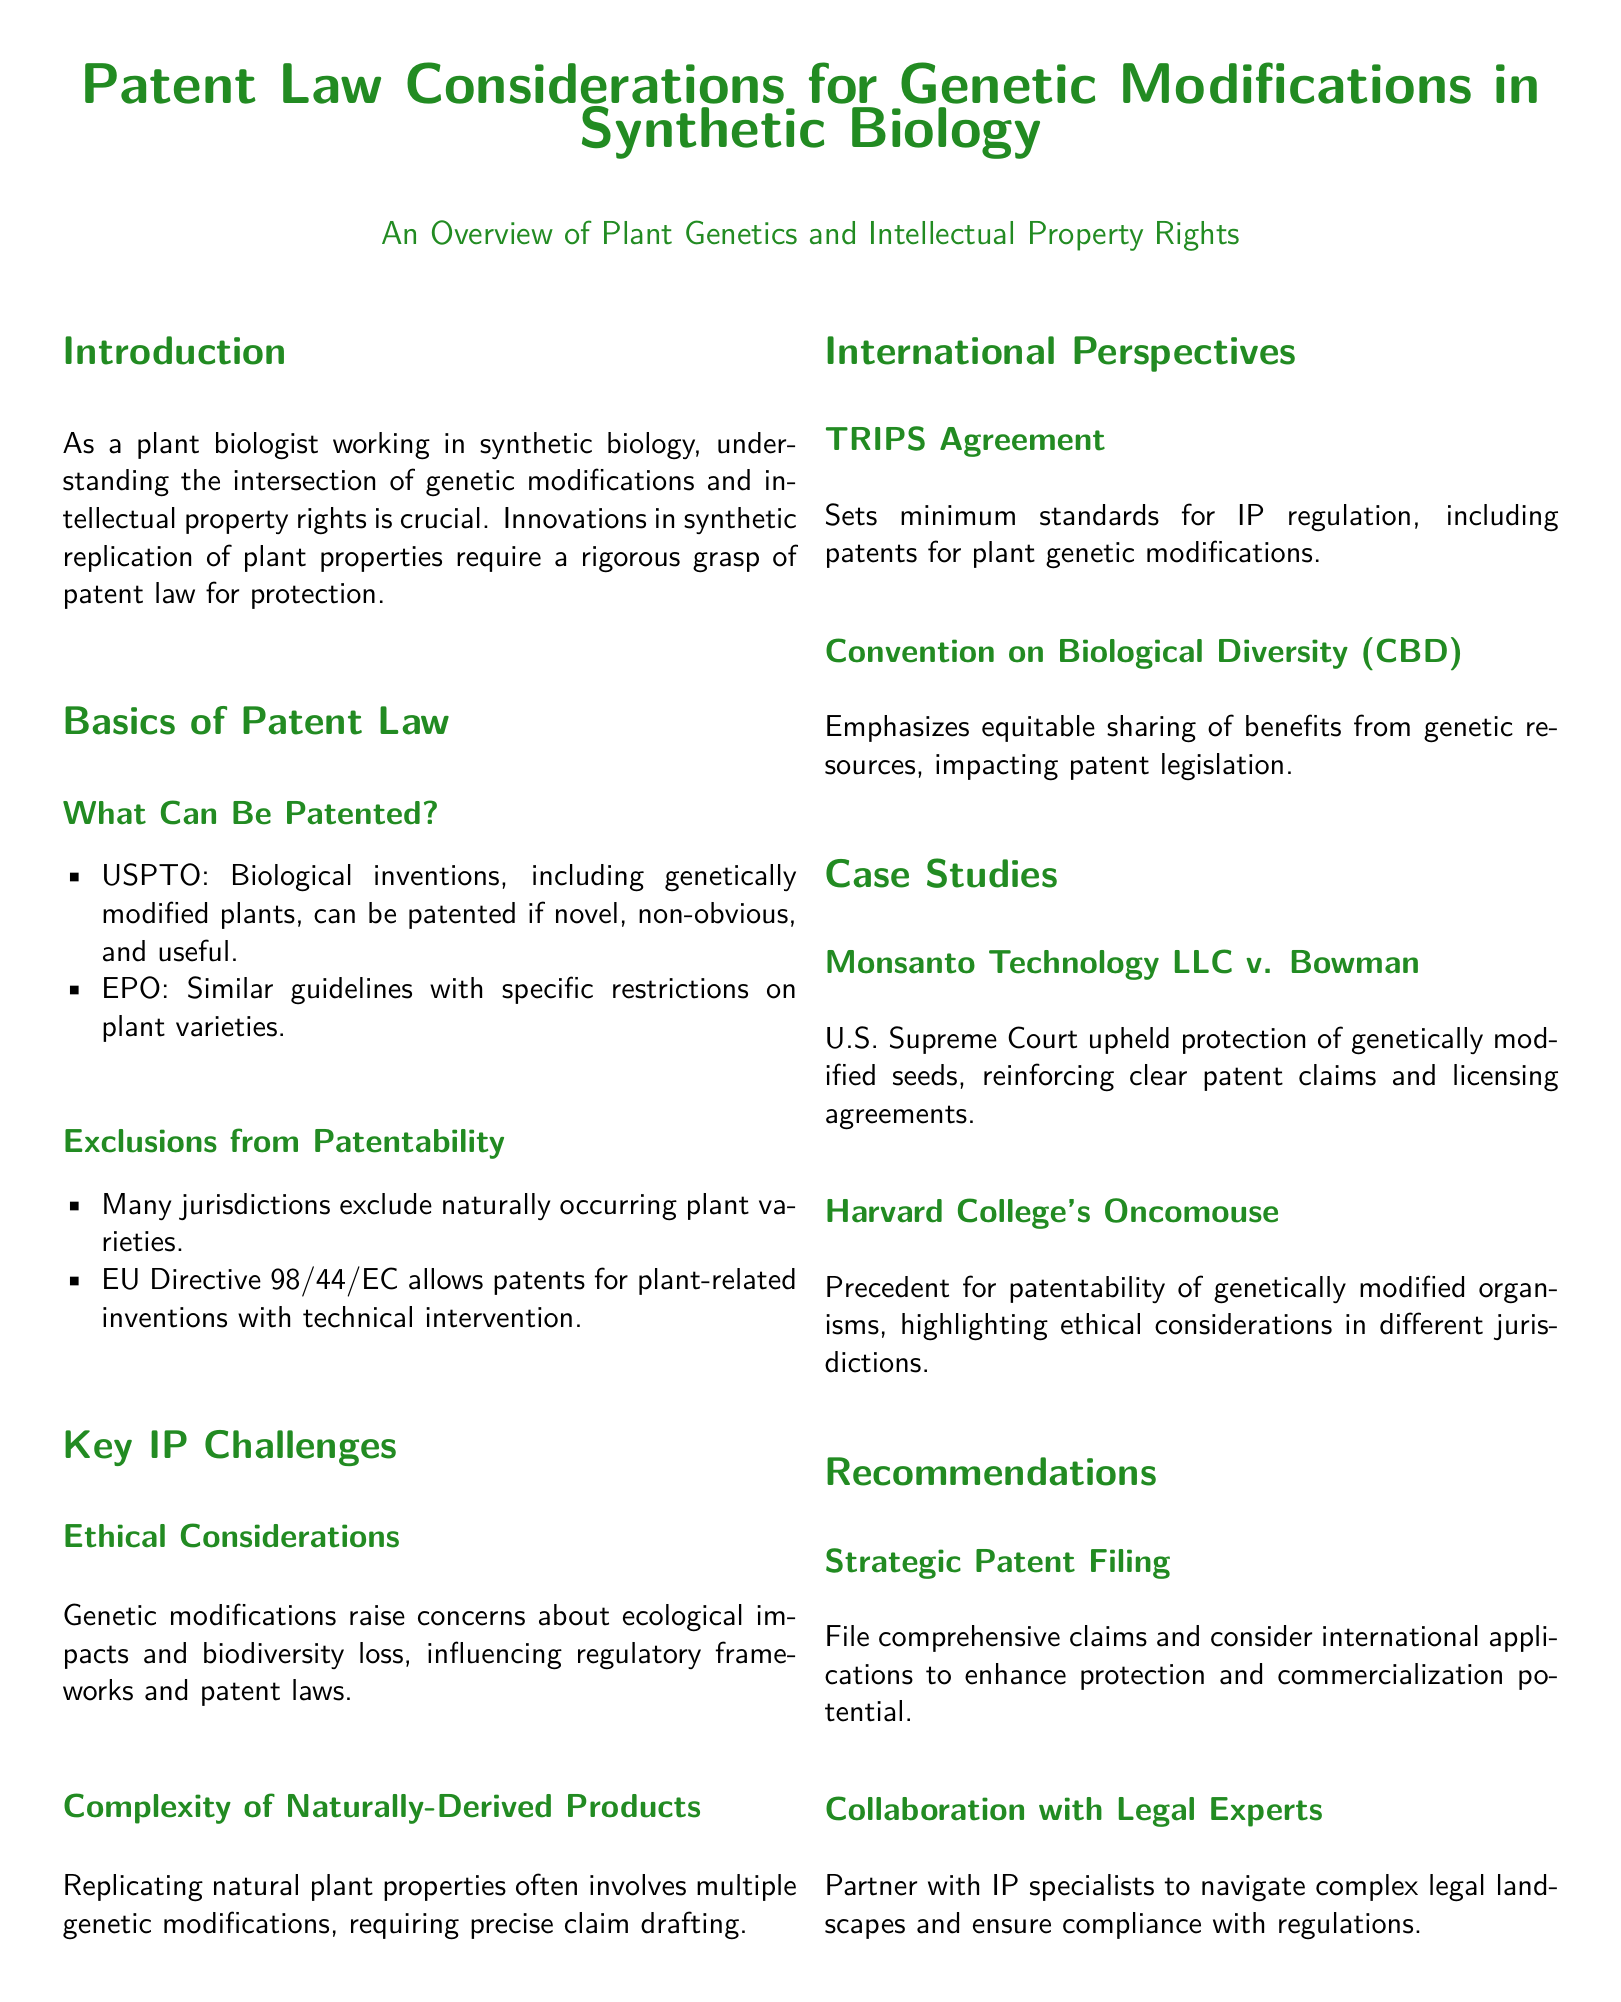What is the title of the document? The title is presented prominently at the beginning of the document and summarizes the main focus on patent law and genetic modifications in synthetic biology.
Answer: Patent Law Considerations for Genetic Modifications in Synthetic Biology What organization provides guidelines for patenting biological inventions in the U.S.? The document mentions the United States Patent and Trademark Office as the organization that sets guidelines for biological inventions.
Answer: USPTO What are the criteria for patentability listed in the document? The document outlines that biological inventions must be novel, non-obvious, and useful to be patentable.
Answer: Novel, non-obvious, useful Which directive allows patents for plant-related inventions in the EU? The relevant European Union directive mentioned in the document is specifically focused on plant-related inventions.
Answer: EU Directive 98/44/EC What does the TRIPS Agreement set? The TRIPS Agreement is referenced as a framework setting minimum standards for intellectual property rights regulation, including patents.
Answer: Minimum standards Which case upheld the patent protection of genetically modified seeds? The case referenced in this context directly relates to the Supreme Court's decision regarding patented seeds, exemplifying legal precedence in patent law.
Answer: Monsanto Technology LLC v. Bowman What does CBD emphasize regarding genetic resources? The document states that the Convention on Biological Diversity emphasizes a key principle regarding benefits sharing from genetic resources.
Answer: Equitable sharing What is recommended for enhancing patent protection? The document advises on a specific strategy to enhance protection and potential commercialization through a certain approach.
Answer: Strategic Patent Filing Who should one collaborate with to navigate complex legal landscapes? The recommendation in the document specifies collaborating with a particular type of expert to ensure compliance with regulations.
Answer: Legal Experts 